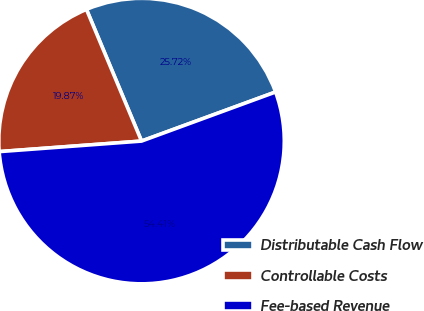Convert chart to OTSL. <chart><loc_0><loc_0><loc_500><loc_500><pie_chart><fcel>Distributable Cash Flow<fcel>Controllable Costs<fcel>Fee-based Revenue<nl><fcel>25.72%<fcel>19.87%<fcel>54.41%<nl></chart> 